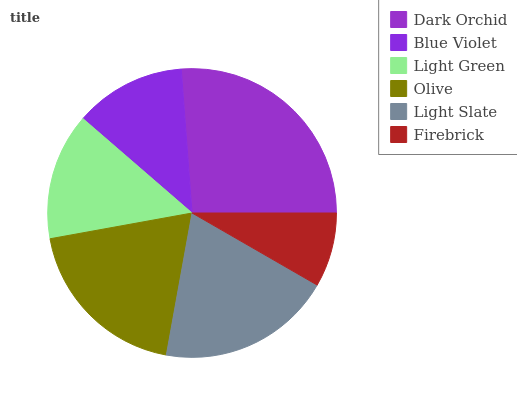Is Firebrick the minimum?
Answer yes or no. Yes. Is Dark Orchid the maximum?
Answer yes or no. Yes. Is Blue Violet the minimum?
Answer yes or no. No. Is Blue Violet the maximum?
Answer yes or no. No. Is Dark Orchid greater than Blue Violet?
Answer yes or no. Yes. Is Blue Violet less than Dark Orchid?
Answer yes or no. Yes. Is Blue Violet greater than Dark Orchid?
Answer yes or no. No. Is Dark Orchid less than Blue Violet?
Answer yes or no. No. Is Olive the high median?
Answer yes or no. Yes. Is Light Green the low median?
Answer yes or no. Yes. Is Blue Violet the high median?
Answer yes or no. No. Is Olive the low median?
Answer yes or no. No. 